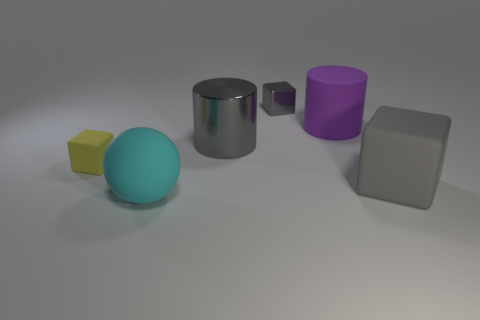Are there any cyan rubber balls to the right of the metal block? no 